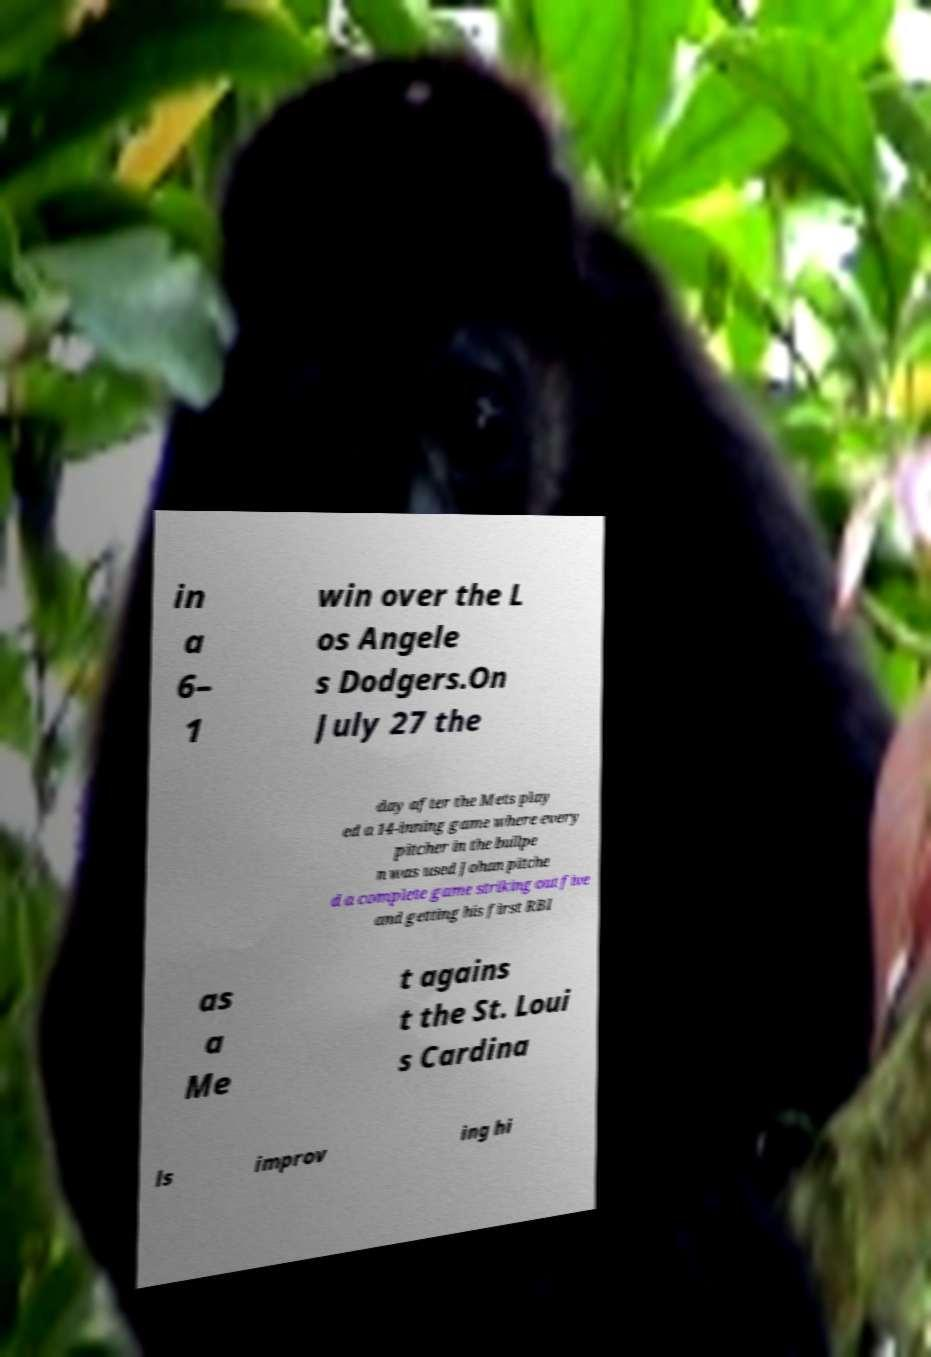There's text embedded in this image that I need extracted. Can you transcribe it verbatim? in a 6– 1 win over the L os Angele s Dodgers.On July 27 the day after the Mets play ed a 14-inning game where every pitcher in the bullpe n was used Johan pitche d a complete game striking out five and getting his first RBI as a Me t agains t the St. Loui s Cardina ls improv ing hi 